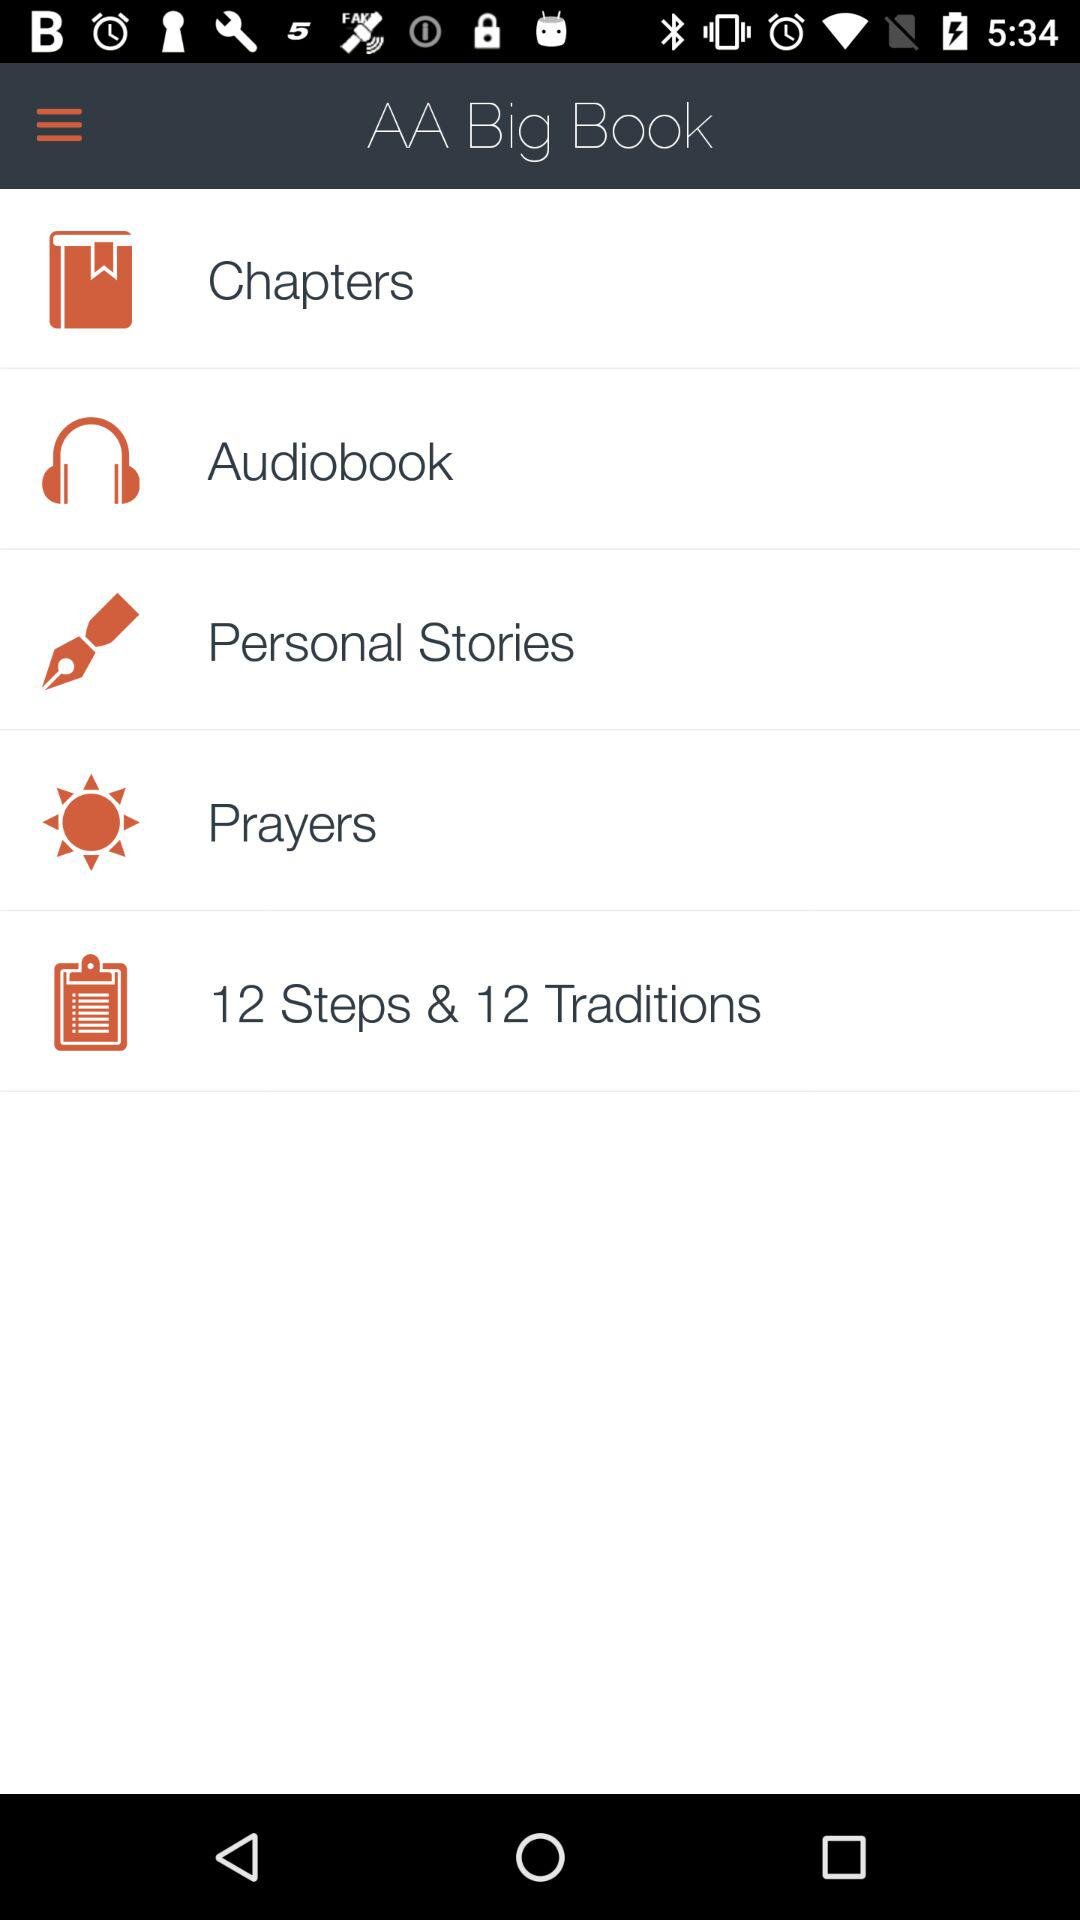How many steps are there? There are 12 steps. 